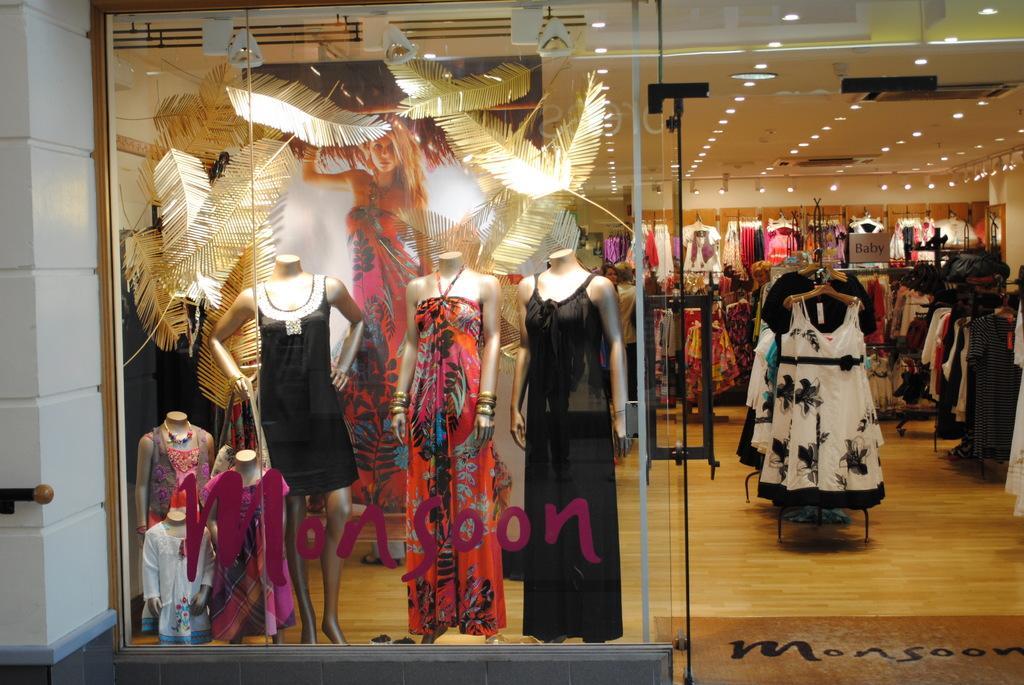Could you give a brief overview of what you see in this image? In this image we can see a garment shop. In display some nights are there. The floor is furnished with wood. The roof and wall of the shop is in white color. 